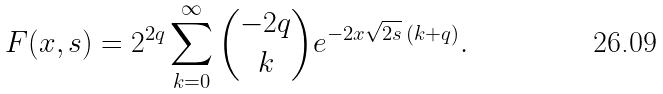<formula> <loc_0><loc_0><loc_500><loc_500>F ( x , s ) = 2 ^ { 2 q } \sum _ { k = 0 } ^ { \infty } \binom { - 2 q } { k } e ^ { - 2 x \sqrt { 2 s } \, ( k + q ) } .</formula> 